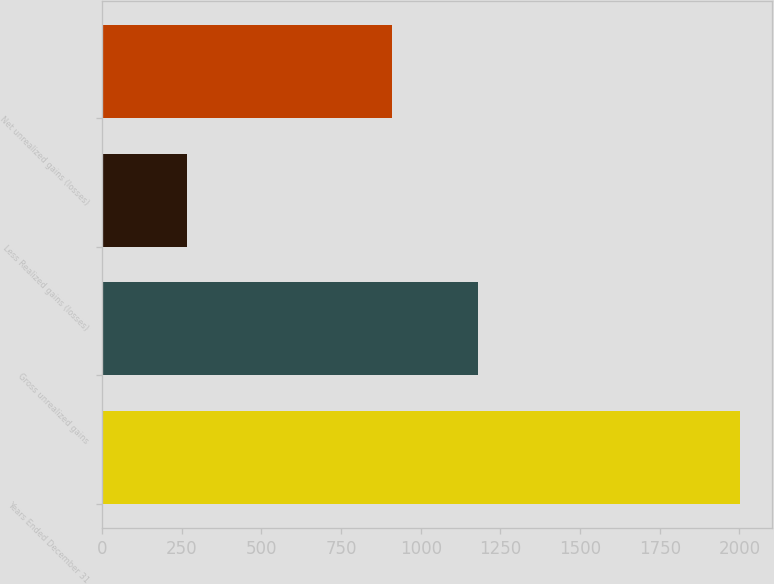Convert chart. <chart><loc_0><loc_0><loc_500><loc_500><bar_chart><fcel>Years Ended December 31<fcel>Gross unrealized gains<fcel>Less Realized gains (losses)<fcel>Net unrealized gains (losses)<nl><fcel>2003<fcel>1179<fcel>268<fcel>911<nl></chart> 